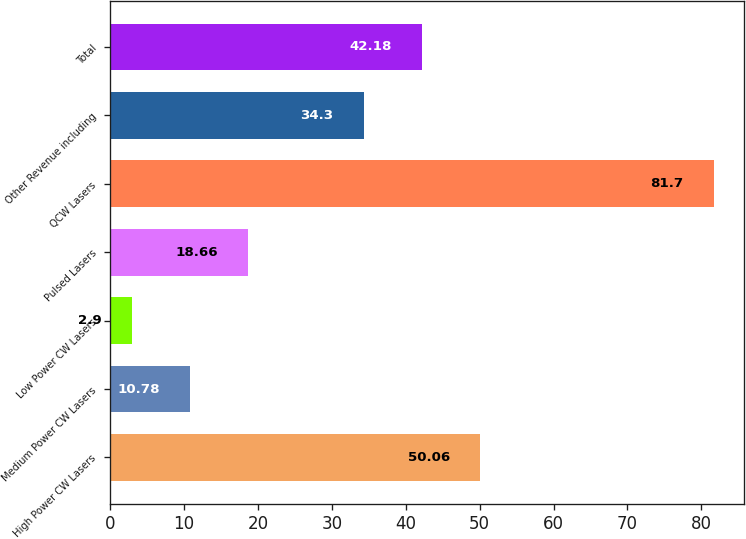<chart> <loc_0><loc_0><loc_500><loc_500><bar_chart><fcel>High Power CW Lasers<fcel>Medium Power CW Lasers<fcel>Low Power CW Lasers<fcel>Pulsed Lasers<fcel>QCW Lasers<fcel>Other Revenue including<fcel>Total<nl><fcel>50.06<fcel>10.78<fcel>2.9<fcel>18.66<fcel>81.7<fcel>34.3<fcel>42.18<nl></chart> 